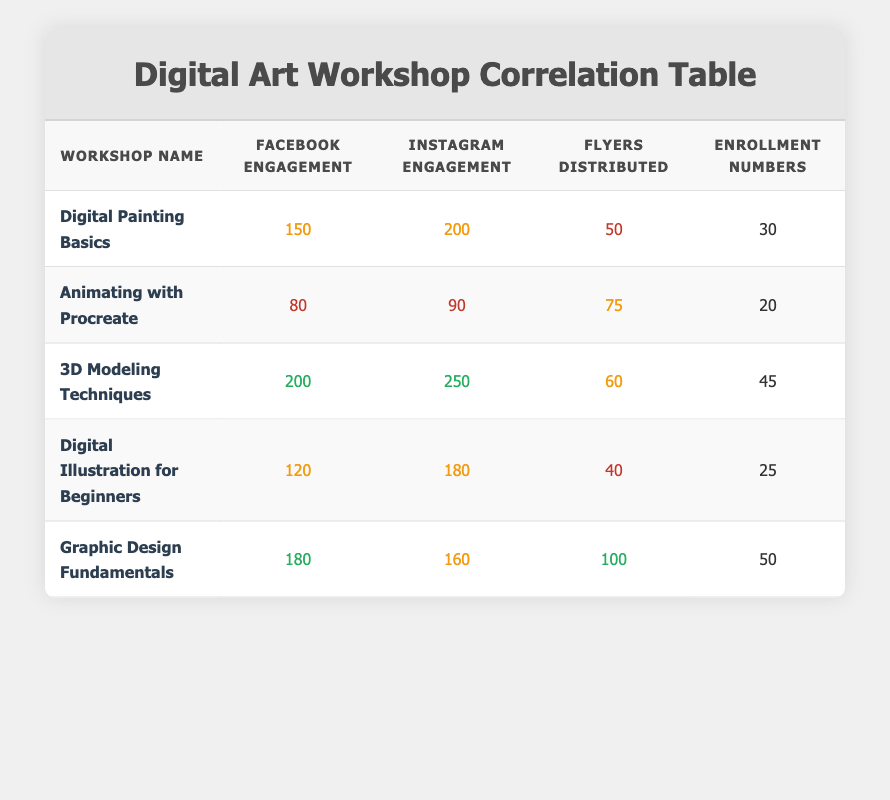What is the highest Facebook engagement among the workshops? The table lists Facebook engagement values for each workshop. The highest engagement value is 200 from the workshop "3D Modeling Techniques."
Answer: 200 Which workshop had the lowest enrollment numbers? By examining the enrollment numbers for each workshop, "Animating with Procreate" has the lowest value of 20.
Answer: 20 What is the total number of flyers distributed across all workshops? To find the total, we add the flyers distributed from each row: 50 + 75 + 60 + 40 + 100 = 325.
Answer: 325 Is there a workshop with more than 200 Instagram engagements and enrollment numbers above 30? Checking the table, "3D Modeling Techniques" meets this criterion with 250 Instagram engagements and 45 enrollment numbers.
Answer: Yes What is the average enrollment number from all workshops listed? The enrollment numbers are 30, 20, 45, 25, and 50. Their sum is 30 + 20 + 45 + 25 + 50 = 170. Dividing by the number of workshops (5), the average is 170 / 5 = 34.
Answer: 34 Which workshop has the highest correlation between flyers distributed and enrollment numbers? To analyze the correlation, we can look for the highest flyers distributed in relation to enrollment. "Graphic Design Fundamentals" has the highest at 100 flyers and 50 enrollments, suggesting a strong correlation.
Answer: Graphic Design Fundamentals How many workshops had more than 150 Facebook engagement but less than 200 enrollment numbers? The workshops with Facebook engagement greater than 150 are "Digital Painting Basics" (150), "3D Modeling Techniques" (200), and "Graphic Design Fundamentals" (180). However, their enrollment numbers (30, 45, 50) are all below 200. Thus, no workshop meets that criteria.
Answer: None What is the difference in enrollment numbers between the workshop with the highest and lowest Instagram engagement? The highest Instagram engagement is from "3D Modeling Techniques" (250 engagements) and the lowest is "Animating with Procreate" (90 engagements). Their corresponding enrollment numbers are 45 and 20. The difference is 45 - 20 = 25.
Answer: 25 In how many workshops were at least 60 flyers distributed? The workshops with 60 or more flyers distributed are "Animating with Procreate" (75 flyers), "3D Modeling Techniques" (60 flyers), and "Graphic Design Fundamentals" (100 flyers). This gives us a total of 3 workshops.
Answer: 3 